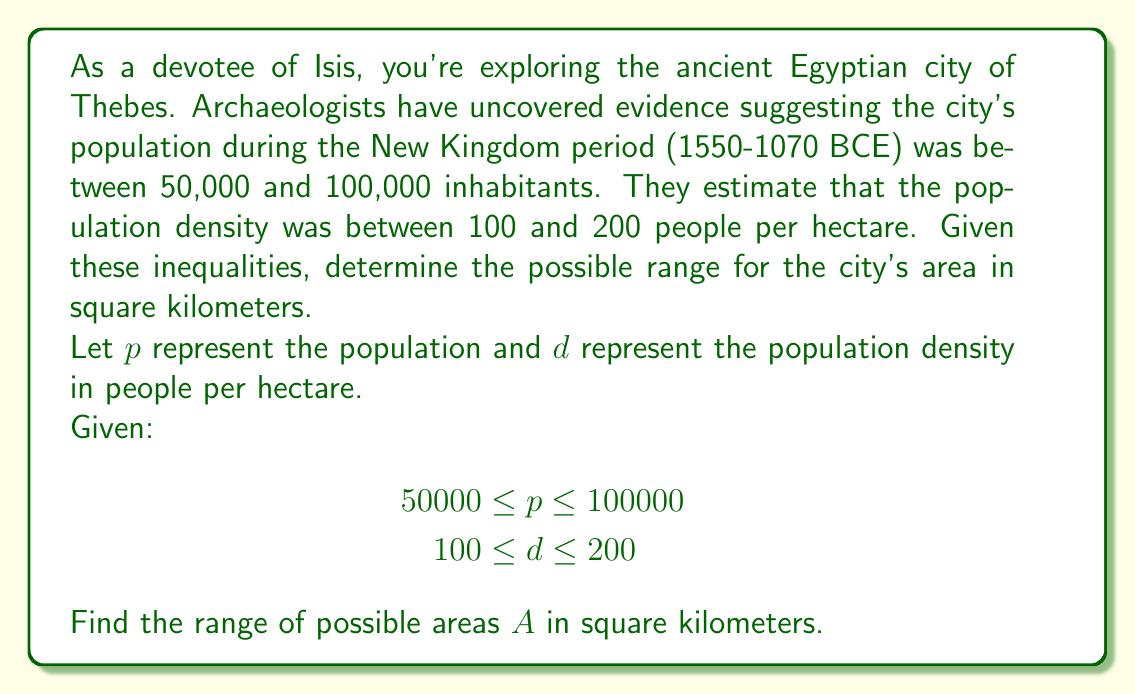What is the answer to this math problem? Let's approach this step-by-step:

1) First, we need to set up the equation for area. Area (in hectares) = Population / Population Density

   $A = \frac{p}{d}$

2) To find the minimum possible area, we use the minimum population and maximum density:

   $A_{min} = \frac{50000}{200} = 250$ hectares

3) To find the maximum possible area, we use the maximum population and minimum density:

   $A_{max} = \frac{100000}{100} = 1000$ hectares

4) Now we have our inequality for area in hectares:

   $250 \leq A \leq 1000$

5) To convert this to square kilometers, we divide by 100 (since 1 km² = 100 hectares):

   $\frac{250}{100} \leq A \leq \frac{1000}{100}$

   $2.5 \leq A \leq 10$

Therefore, the possible range for the city's area is between 2.5 and 10 square kilometers.

This aligns with archaeological evidence suggesting that ancient Egyptian cities were relatively compact, with high population densities. The range accounts for variations in city planning, the inclusion of temple complexes, and potential suburban areas dedicated to agriculture.
Answer: The possible range for the area of ancient Thebes during the New Kingdom period is:

$2.5 \leq A \leq 10$ square kilometers 